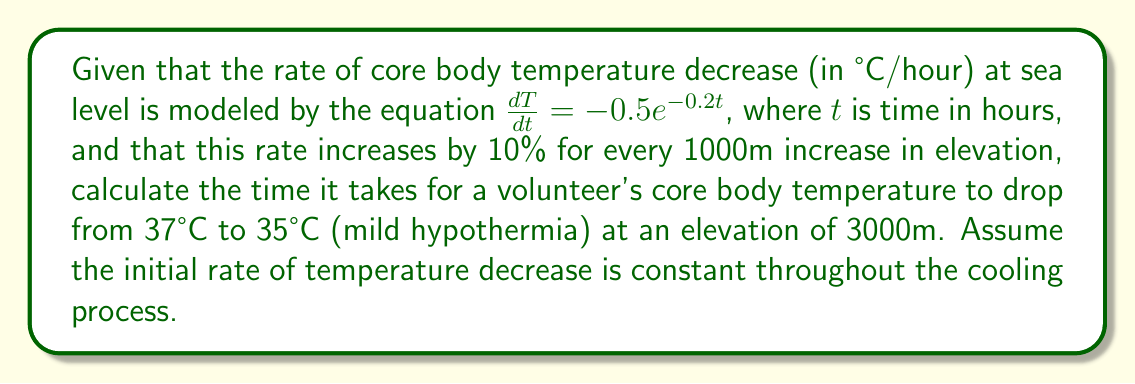Could you help me with this problem? 1) First, we need to adjust the rate of temperature decrease for the given elevation:
   At 3000m, the rate increases by 30% (10% per 1000m).
   New rate = $-0.5e^{-0.2t} \times 1.3 = -0.65e^{-0.2t}$

2) Since we're assuming a constant initial rate, we can use the rate at t=0:
   Rate at t=0: $-0.65e^{-0.2(0)} = -0.65$ °C/hour

3) Now, we need to find the time it takes for the temperature to drop by 2°C (from 37°C to 35°C):
   $$\Delta T = \text{Rate} \times \text{Time}$$
   $$-2 = -0.65 \times t$$

4) Solve for t:
   $$t = \frac{-2}{-0.65} = \frac{2}{0.65} \approx 3.0769$$

5) Convert to hours and minutes:
   3.0769 hours = 3 hours and 0.0769 × 60 ≈ 4.6 minutes
Answer: 3 hours and 5 minutes 